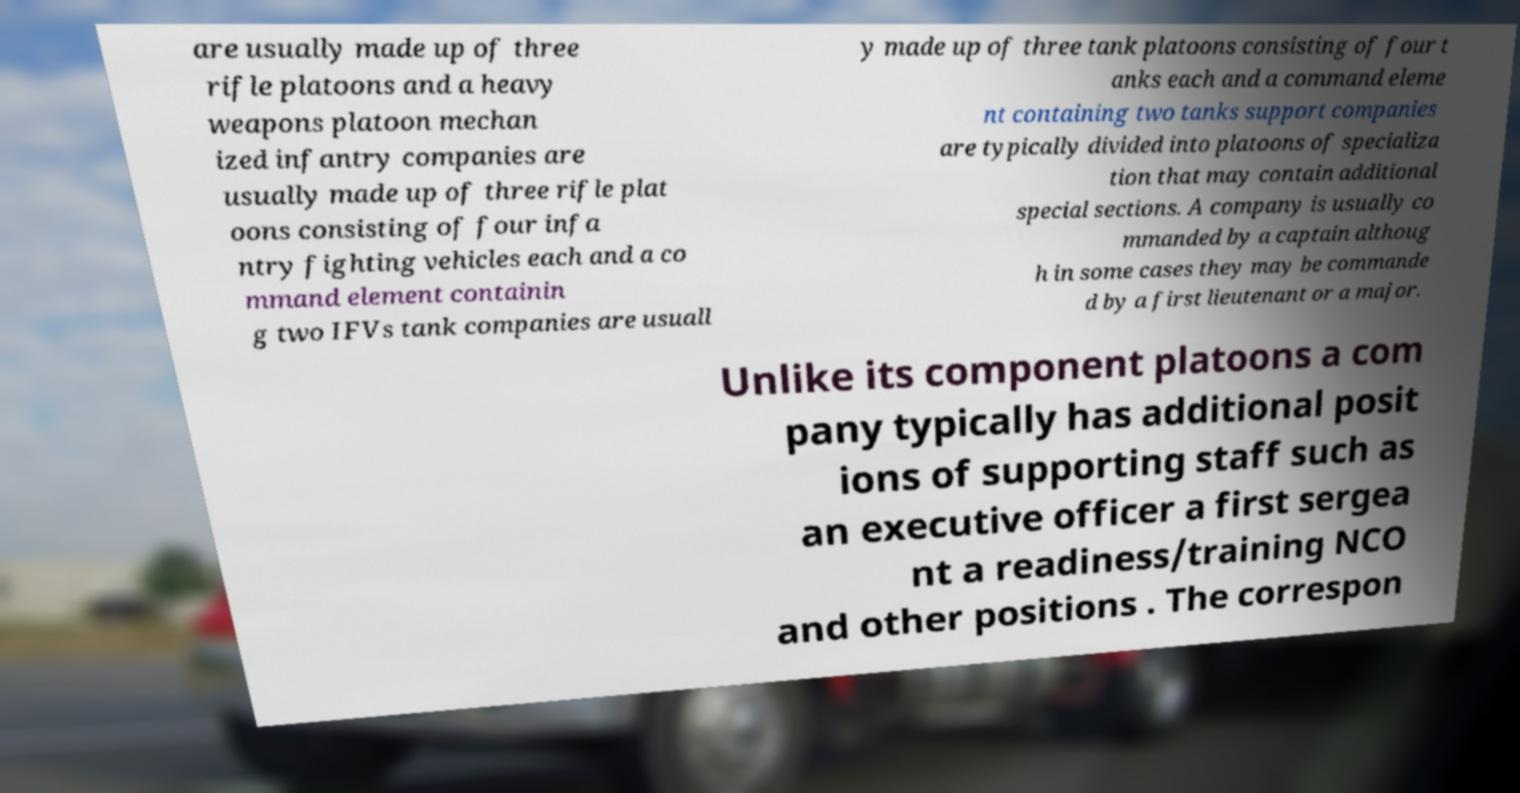I need the written content from this picture converted into text. Can you do that? are usually made up of three rifle platoons and a heavy weapons platoon mechan ized infantry companies are usually made up of three rifle plat oons consisting of four infa ntry fighting vehicles each and a co mmand element containin g two IFVs tank companies are usuall y made up of three tank platoons consisting of four t anks each and a command eleme nt containing two tanks support companies are typically divided into platoons of specializa tion that may contain additional special sections. A company is usually co mmanded by a captain althoug h in some cases they may be commande d by a first lieutenant or a major. Unlike its component platoons a com pany typically has additional posit ions of supporting staff such as an executive officer a first sergea nt a readiness/training NCO and other positions . The correspon 